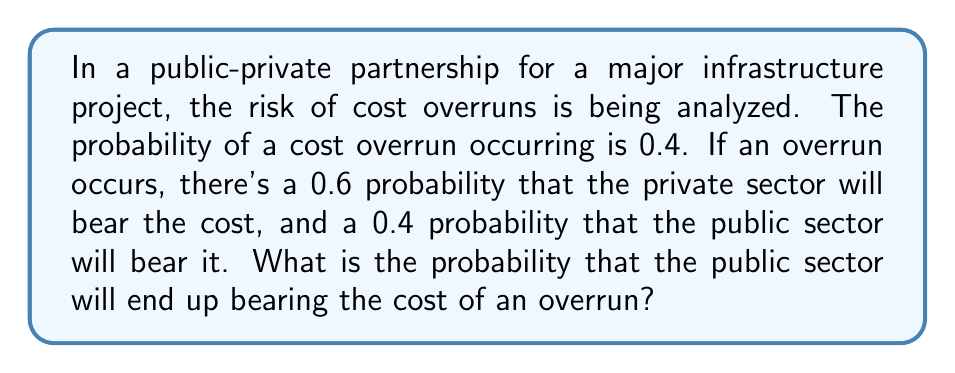What is the answer to this math problem? To solve this problem, we need to use the concept of conditional probability. Let's break it down step-by-step:

1) Let's define our events:
   A: Cost overrun occurs
   B: Public sector bears the cost

2) We're given:
   P(A) = 0.4 (probability of cost overrun)
   P(B|A) = 0.4 (probability public sector bears cost, given an overrun occurs)

3) We want to find P(A and B), which is the probability that both a cost overrun occurs AND the public sector bears the cost.

4) We can use the multiplication rule of probability:
   
   $$ P(A \text{ and } B) = P(A) \cdot P(B|A) $$

5) Substituting our known values:

   $$ P(A \text{ and } B) = 0.4 \cdot 0.4 = 0.16 $$

6) Therefore, the probability that the public sector will bear the cost of an overrun is 0.16 or 16%.

This analysis helps the policy advisor understand the risk distribution between public and private sectors in this partnership. It shows that while the overall risk of cost overrun is 40%, the public sector's exposure to this risk is reduced to 16% through the partnership arrangement.
Answer: 0.16 